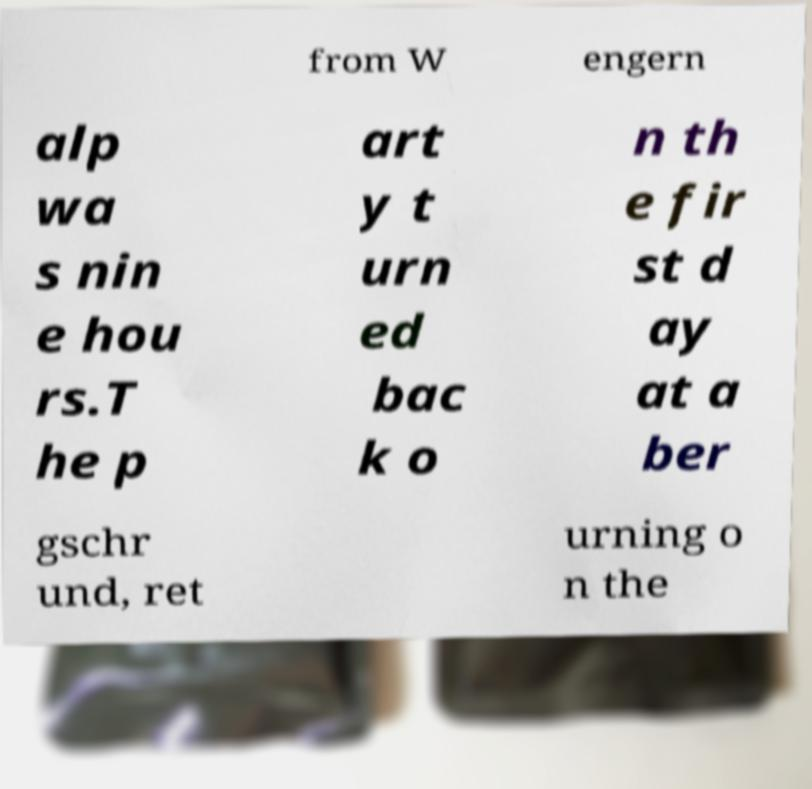Can you read and provide the text displayed in the image?This photo seems to have some interesting text. Can you extract and type it out for me? from W engern alp wa s nin e hou rs.T he p art y t urn ed bac k o n th e fir st d ay at a ber gschr und, ret urning o n the 